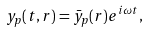Convert formula to latex. <formula><loc_0><loc_0><loc_500><loc_500>y _ { p } ( t , r ) = \bar { y } _ { p } ( r ) e ^ { i \omega t } ,</formula> 